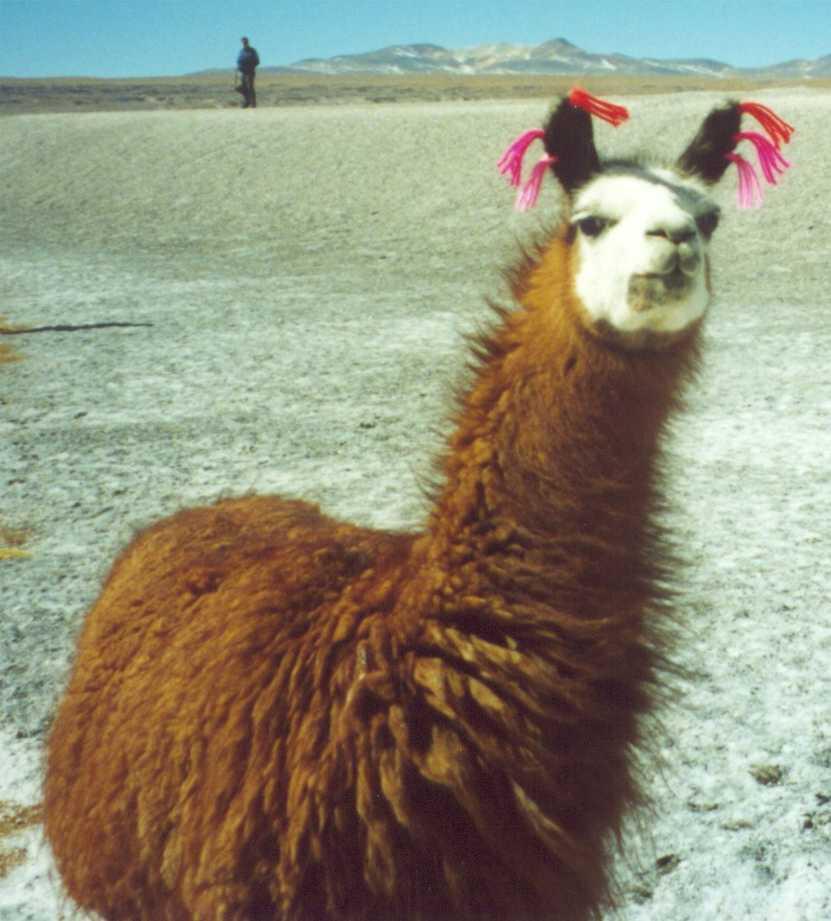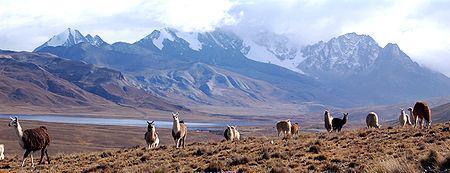The first image is the image on the left, the second image is the image on the right. Assess this claim about the two images: "One image shows a single brownish llama with its head angled rightward and red tassles on the ends of its dark upright ears.". Correct or not? Answer yes or no. Yes. The first image is the image on the left, the second image is the image on the right. Analyze the images presented: Is the assertion "an alpaca has tassles dangling from its ears" valid? Answer yes or no. Yes. 